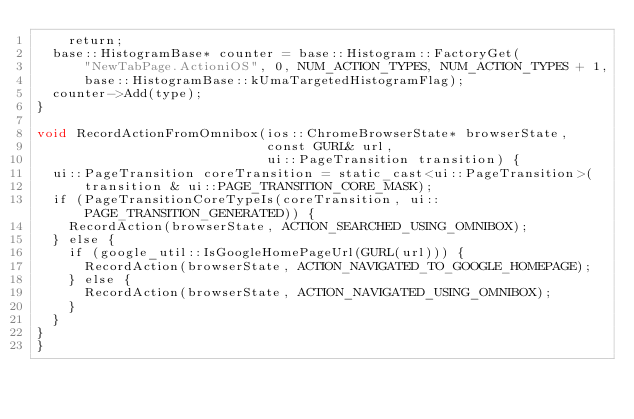Convert code to text. <code><loc_0><loc_0><loc_500><loc_500><_ObjectiveC_>    return;
  base::HistogramBase* counter = base::Histogram::FactoryGet(
      "NewTabPage.ActioniOS", 0, NUM_ACTION_TYPES, NUM_ACTION_TYPES + 1,
      base::HistogramBase::kUmaTargetedHistogramFlag);
  counter->Add(type);
}

void RecordActionFromOmnibox(ios::ChromeBrowserState* browserState,
                             const GURL& url,
                             ui::PageTransition transition) {
  ui::PageTransition coreTransition = static_cast<ui::PageTransition>(
      transition & ui::PAGE_TRANSITION_CORE_MASK);
  if (PageTransitionCoreTypeIs(coreTransition, ui::PAGE_TRANSITION_GENERATED)) {
    RecordAction(browserState, ACTION_SEARCHED_USING_OMNIBOX);
  } else {
    if (google_util::IsGoogleHomePageUrl(GURL(url))) {
      RecordAction(browserState, ACTION_NAVIGATED_TO_GOOGLE_HOMEPAGE);
    } else {
      RecordAction(browserState, ACTION_NAVIGATED_USING_OMNIBOX);
    }
  }
}
}
</code> 